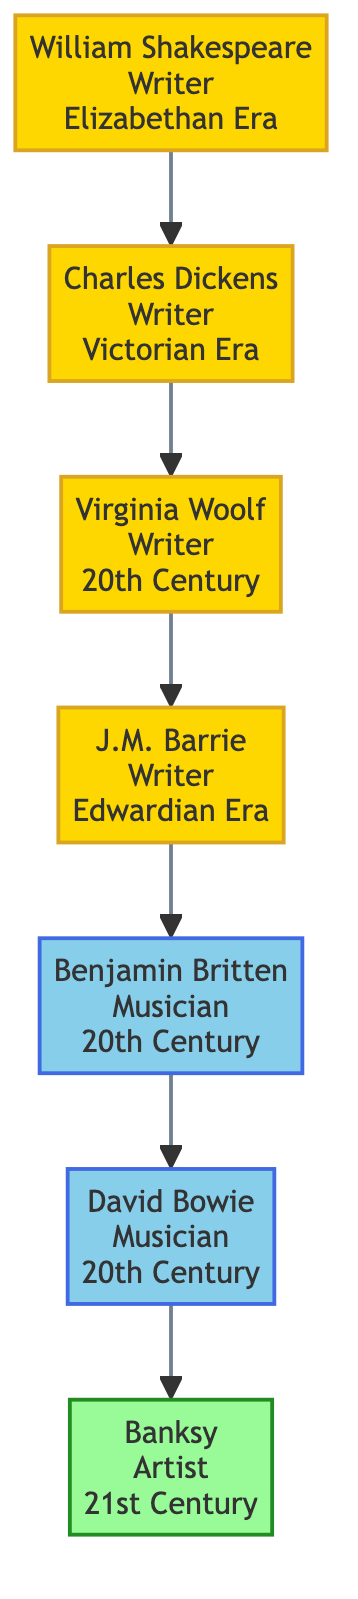What is the era of William Shakespeare? From the diagram, William Shakespeare is labeled with "Elizabethan" under the era description.
Answer: Elizabethan How many writers are connected to Charles Dickens? The diagram shows that Charles Dickens is connected to two other writers: William Shakespeare and Virginia Woolf, making a total of two connections.
Answer: 2 Which musician is connected to J.M. Barrie? Looking at the diagram, J.M. Barrie has a connection to Benjamin Britten listed right next to him.
Answer: Benjamin Britten What works are associated with Virginia Woolf? The diagram lists "Mrs Dalloway," "To the Lighthouse," and "Orlando" directly under Virginia Woolf's name, signifying her notable works.
Answer: Mrs Dalloway, To the Lighthouse, Orlando Who is the last person in the hierarchy? The diagram shows that Banksy is the final node in terms of connections, being connected to David Bowie but having no connections coming out from him.
Answer: Banksy Name a connection between music and literature in this tree. Tracing the connections, we see that Benjamin Britten (a musician) is connected to J.M. Barrie (a writer), illustrating a relationship between these two domains.
Answer: Benjamin Britten and J.M. Barrie Which artist is known for the work "Girl with Balloon"? The diagram specifically states that Banksy is the artist associated with "Girl with Balloon," thus directly tying the work to him.
Answer: Banksy How many musicians are shown in this diagram? Within the elements highlighted in the diagram, there are two musicians: Benjamin Britten and David Bowie, indicated by their colored nodes.
Answer: 2 What literary era is Virginia Woolf part of? The diagram displays "20th Century" under Virginia Woolf's name, which categorizes her into this specific literary era.
Answer: 20th Century 